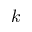<formula> <loc_0><loc_0><loc_500><loc_500>k</formula> 